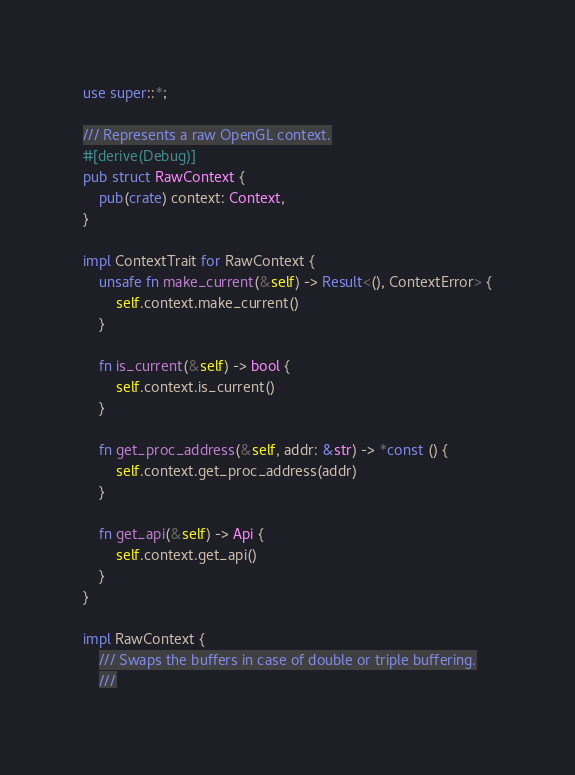Convert code to text. <code><loc_0><loc_0><loc_500><loc_500><_Rust_>use super::*;

/// Represents a raw OpenGL context.
#[derive(Debug)]
pub struct RawContext {
    pub(crate) context: Context,
}

impl ContextTrait for RawContext {
    unsafe fn make_current(&self) -> Result<(), ContextError> {
        self.context.make_current()
    }

    fn is_current(&self) -> bool {
        self.context.is_current()
    }

    fn get_proc_address(&self, addr: &str) -> *const () {
        self.context.get_proc_address(addr)
    }

    fn get_api(&self) -> Api {
        self.context.get_api()
    }
}

impl RawContext {
    /// Swaps the buffers in case of double or triple buffering.
    ///</code> 